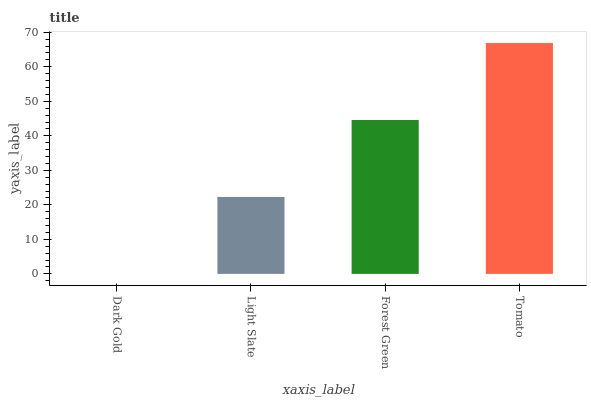Is Light Slate the minimum?
Answer yes or no. No. Is Light Slate the maximum?
Answer yes or no. No. Is Light Slate greater than Dark Gold?
Answer yes or no. Yes. Is Dark Gold less than Light Slate?
Answer yes or no. Yes. Is Dark Gold greater than Light Slate?
Answer yes or no. No. Is Light Slate less than Dark Gold?
Answer yes or no. No. Is Forest Green the high median?
Answer yes or no. Yes. Is Light Slate the low median?
Answer yes or no. Yes. Is Dark Gold the high median?
Answer yes or no. No. Is Dark Gold the low median?
Answer yes or no. No. 